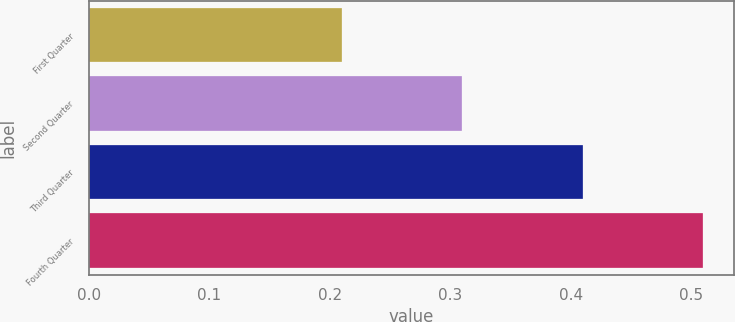<chart> <loc_0><loc_0><loc_500><loc_500><bar_chart><fcel>First Quarter<fcel>Second Quarter<fcel>Third Quarter<fcel>Fourth Quarter<nl><fcel>0.21<fcel>0.31<fcel>0.41<fcel>0.51<nl></chart> 